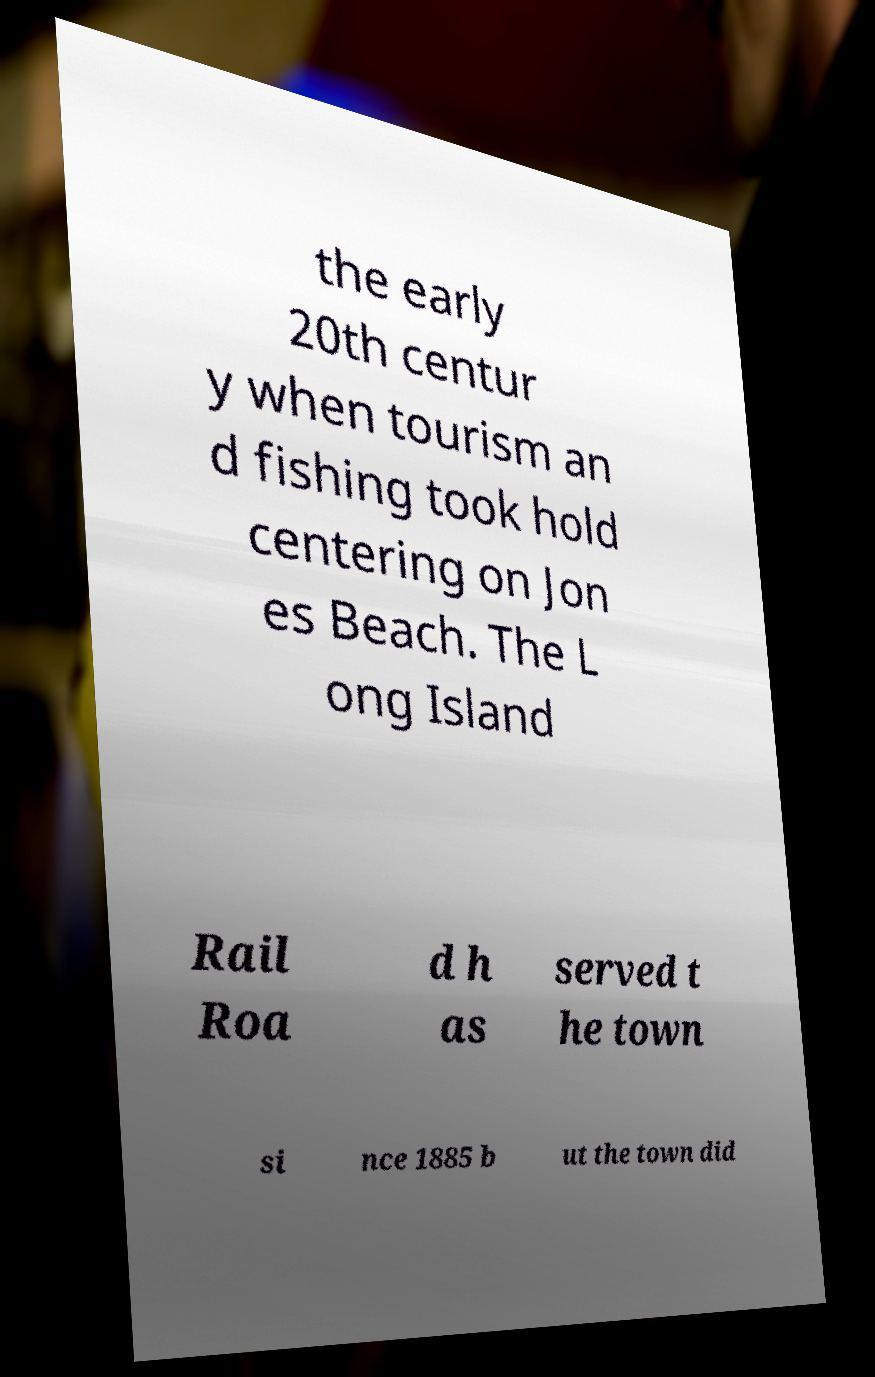Can you accurately transcribe the text from the provided image for me? the early 20th centur y when tourism an d fishing took hold centering on Jon es Beach. The L ong Island Rail Roa d h as served t he town si nce 1885 b ut the town did 